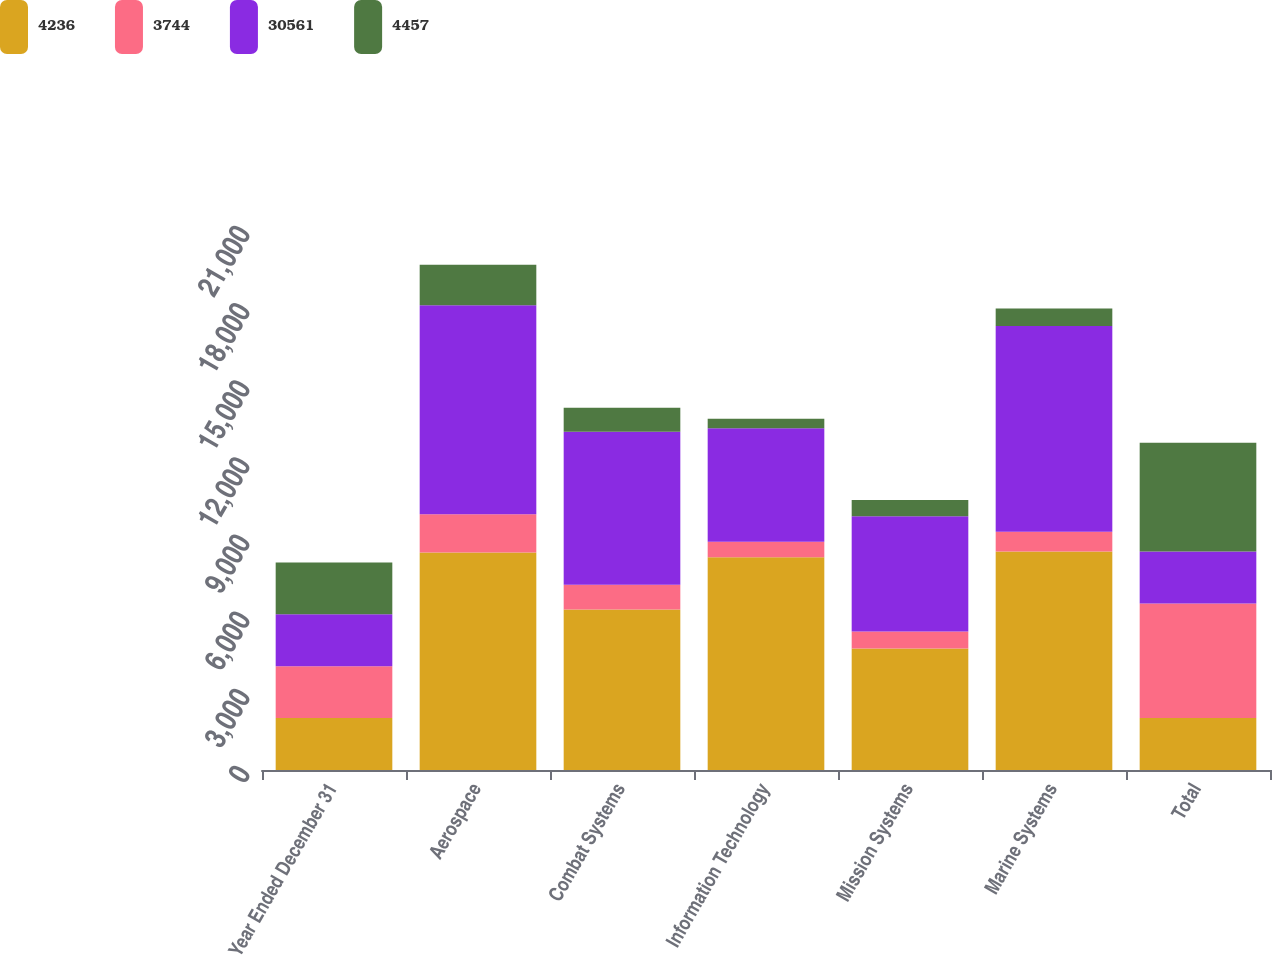<chart> <loc_0><loc_0><loc_500><loc_500><stacked_bar_chart><ecel><fcel>Year Ended December 31<fcel>Aerospace<fcel>Combat Systems<fcel>Information Technology<fcel>Mission Systems<fcel>Marine Systems<fcel>Total<nl><fcel>4236<fcel>2018<fcel>8455<fcel>6241<fcel>8269<fcel>4726<fcel>8502<fcel>2018<nl><fcel>3744<fcel>2018<fcel>1490<fcel>962<fcel>608<fcel>659<fcel>761<fcel>4457<nl><fcel>30561<fcel>2017<fcel>8129<fcel>5949<fcel>4410<fcel>4481<fcel>8004<fcel>2018<nl><fcel>4457<fcel>2017<fcel>1577<fcel>937<fcel>373<fcel>638<fcel>685<fcel>4236<nl></chart> 